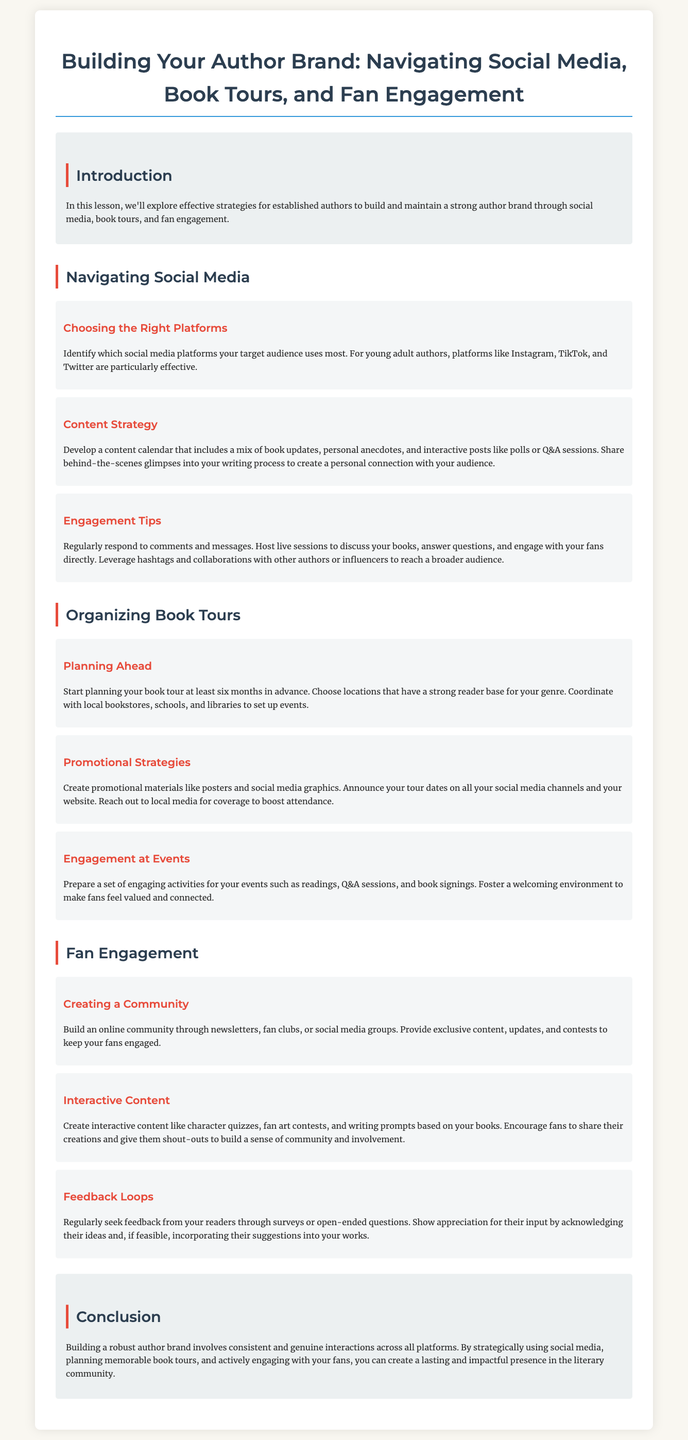what are effective social media platforms for young adult authors? The document states that Instagram, TikTok, and Twitter are particularly effective platforms for young adult authors.
Answer: Instagram, TikTok, Twitter how far in advance should you start planning your book tour? According to the document, you should start planning your book tour at least six months in advance.
Answer: six months what type of content should your content calendar include? The document suggests including book updates, personal anecdotes, and interactive posts like polls or Q&A sessions in your content calendar.
Answer: book updates, personal anecdotes, interactive posts what activities are recommended for engagement at events? The document mentions readings, Q&A sessions, and book signings as recommended activities for engagement at events.
Answer: readings, Q&A sessions, book signings what approach is suggested for seeking feedback from readers? The document advises regularly seeking feedback from readers through surveys or open-ended questions.
Answer: surveys or open-ended questions how can you create a sense of community among fans? According to the document, build an online community through newsletters, fan clubs, or social media groups to create a sense of community.
Answer: newsletters, fan clubs, or social media groups 